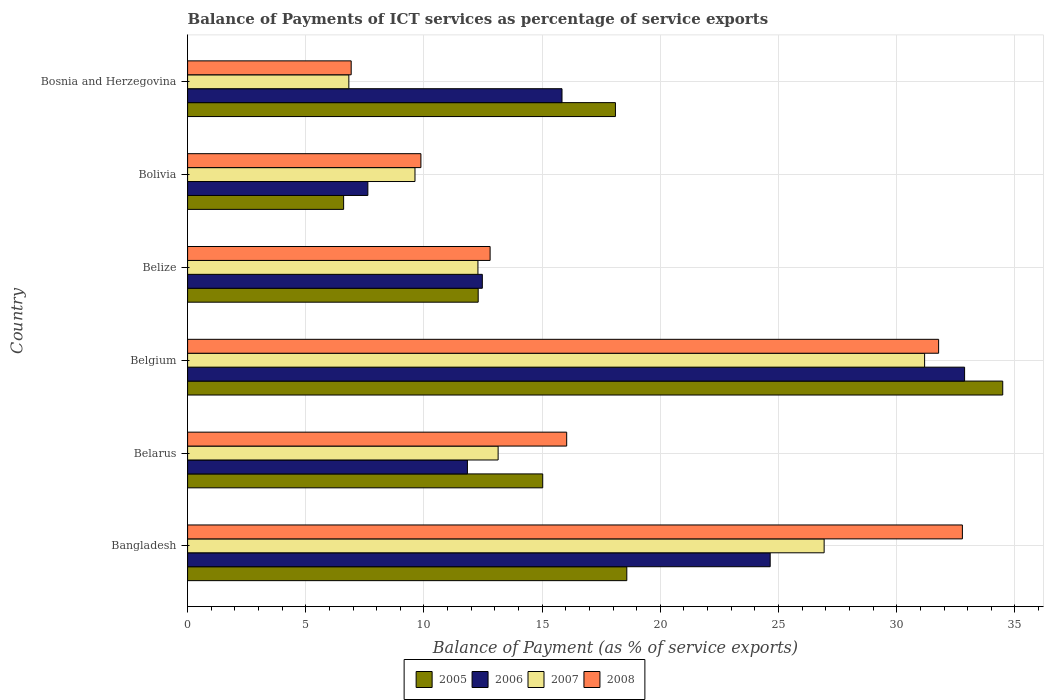How many different coloured bars are there?
Your response must be concise. 4. How many groups of bars are there?
Provide a short and direct response. 6. Are the number of bars per tick equal to the number of legend labels?
Provide a succinct answer. Yes. How many bars are there on the 1st tick from the top?
Your answer should be very brief. 4. How many bars are there on the 2nd tick from the bottom?
Your answer should be very brief. 4. What is the label of the 5th group of bars from the top?
Your answer should be very brief. Belarus. What is the balance of payments of ICT services in 2007 in Belarus?
Provide a succinct answer. 13.14. Across all countries, what is the maximum balance of payments of ICT services in 2007?
Make the answer very short. 31.18. Across all countries, what is the minimum balance of payments of ICT services in 2005?
Keep it short and to the point. 6.6. In which country was the balance of payments of ICT services in 2006 minimum?
Your answer should be compact. Bolivia. What is the total balance of payments of ICT services in 2006 in the graph?
Ensure brevity in your answer.  105.29. What is the difference between the balance of payments of ICT services in 2007 in Belgium and that in Bolivia?
Ensure brevity in your answer.  21.56. What is the difference between the balance of payments of ICT services in 2006 in Bangladesh and the balance of payments of ICT services in 2007 in Belgium?
Ensure brevity in your answer.  -6.53. What is the average balance of payments of ICT services in 2005 per country?
Your answer should be very brief. 17.51. What is the difference between the balance of payments of ICT services in 2008 and balance of payments of ICT services in 2006 in Belarus?
Your answer should be very brief. 4.2. What is the ratio of the balance of payments of ICT services in 2005 in Belize to that in Bolivia?
Provide a succinct answer. 1.86. Is the difference between the balance of payments of ICT services in 2008 in Bangladesh and Bolivia greater than the difference between the balance of payments of ICT services in 2006 in Bangladesh and Bolivia?
Ensure brevity in your answer.  Yes. What is the difference between the highest and the second highest balance of payments of ICT services in 2008?
Provide a succinct answer. 1.01. What is the difference between the highest and the lowest balance of payments of ICT services in 2005?
Offer a terse response. 27.88. Is it the case that in every country, the sum of the balance of payments of ICT services in 2007 and balance of payments of ICT services in 2008 is greater than the balance of payments of ICT services in 2006?
Your answer should be compact. No. How many bars are there?
Ensure brevity in your answer.  24. How many countries are there in the graph?
Your answer should be very brief. 6. Are the values on the major ticks of X-axis written in scientific E-notation?
Provide a succinct answer. No. Does the graph contain any zero values?
Make the answer very short. No. What is the title of the graph?
Provide a succinct answer. Balance of Payments of ICT services as percentage of service exports. What is the label or title of the X-axis?
Your answer should be very brief. Balance of Payment (as % of service exports). What is the Balance of Payment (as % of service exports) in 2005 in Bangladesh?
Keep it short and to the point. 18.58. What is the Balance of Payment (as % of service exports) in 2006 in Bangladesh?
Your answer should be very brief. 24.65. What is the Balance of Payment (as % of service exports) of 2007 in Bangladesh?
Your answer should be compact. 26.93. What is the Balance of Payment (as % of service exports) of 2008 in Bangladesh?
Keep it short and to the point. 32.78. What is the Balance of Payment (as % of service exports) in 2005 in Belarus?
Provide a short and direct response. 15.02. What is the Balance of Payment (as % of service exports) in 2006 in Belarus?
Offer a very short reply. 11.84. What is the Balance of Payment (as % of service exports) of 2007 in Belarus?
Give a very brief answer. 13.14. What is the Balance of Payment (as % of service exports) of 2008 in Belarus?
Give a very brief answer. 16.04. What is the Balance of Payment (as % of service exports) in 2005 in Belgium?
Your answer should be very brief. 34.48. What is the Balance of Payment (as % of service exports) in 2006 in Belgium?
Your answer should be very brief. 32.87. What is the Balance of Payment (as % of service exports) in 2007 in Belgium?
Your answer should be compact. 31.18. What is the Balance of Payment (as % of service exports) of 2008 in Belgium?
Your answer should be very brief. 31.77. What is the Balance of Payment (as % of service exports) of 2005 in Belize?
Your response must be concise. 12.29. What is the Balance of Payment (as % of service exports) of 2006 in Belize?
Your answer should be very brief. 12.47. What is the Balance of Payment (as % of service exports) in 2007 in Belize?
Your response must be concise. 12.28. What is the Balance of Payment (as % of service exports) in 2008 in Belize?
Provide a short and direct response. 12.8. What is the Balance of Payment (as % of service exports) of 2005 in Bolivia?
Provide a short and direct response. 6.6. What is the Balance of Payment (as % of service exports) in 2006 in Bolivia?
Provide a succinct answer. 7.63. What is the Balance of Payment (as % of service exports) of 2007 in Bolivia?
Make the answer very short. 9.62. What is the Balance of Payment (as % of service exports) in 2008 in Bolivia?
Your answer should be compact. 9.87. What is the Balance of Payment (as % of service exports) of 2005 in Bosnia and Herzegovina?
Give a very brief answer. 18.1. What is the Balance of Payment (as % of service exports) of 2006 in Bosnia and Herzegovina?
Give a very brief answer. 15.84. What is the Balance of Payment (as % of service exports) of 2007 in Bosnia and Herzegovina?
Your response must be concise. 6.82. What is the Balance of Payment (as % of service exports) in 2008 in Bosnia and Herzegovina?
Offer a very short reply. 6.92. Across all countries, what is the maximum Balance of Payment (as % of service exports) in 2005?
Give a very brief answer. 34.48. Across all countries, what is the maximum Balance of Payment (as % of service exports) in 2006?
Provide a short and direct response. 32.87. Across all countries, what is the maximum Balance of Payment (as % of service exports) in 2007?
Keep it short and to the point. 31.18. Across all countries, what is the maximum Balance of Payment (as % of service exports) of 2008?
Offer a very short reply. 32.78. Across all countries, what is the minimum Balance of Payment (as % of service exports) in 2005?
Make the answer very short. 6.6. Across all countries, what is the minimum Balance of Payment (as % of service exports) in 2006?
Provide a short and direct response. 7.63. Across all countries, what is the minimum Balance of Payment (as % of service exports) in 2007?
Give a very brief answer. 6.82. Across all countries, what is the minimum Balance of Payment (as % of service exports) in 2008?
Ensure brevity in your answer.  6.92. What is the total Balance of Payment (as % of service exports) in 2005 in the graph?
Ensure brevity in your answer.  105.08. What is the total Balance of Payment (as % of service exports) in 2006 in the graph?
Your answer should be very brief. 105.29. What is the total Balance of Payment (as % of service exports) in 2007 in the graph?
Keep it short and to the point. 99.97. What is the total Balance of Payment (as % of service exports) in 2008 in the graph?
Offer a very short reply. 110.18. What is the difference between the Balance of Payment (as % of service exports) of 2005 in Bangladesh and that in Belarus?
Your response must be concise. 3.56. What is the difference between the Balance of Payment (as % of service exports) of 2006 in Bangladesh and that in Belarus?
Provide a succinct answer. 12.81. What is the difference between the Balance of Payment (as % of service exports) in 2007 in Bangladesh and that in Belarus?
Give a very brief answer. 13.79. What is the difference between the Balance of Payment (as % of service exports) in 2008 in Bangladesh and that in Belarus?
Keep it short and to the point. 16.74. What is the difference between the Balance of Payment (as % of service exports) in 2005 in Bangladesh and that in Belgium?
Ensure brevity in your answer.  -15.9. What is the difference between the Balance of Payment (as % of service exports) of 2006 in Bangladesh and that in Belgium?
Offer a very short reply. -8.22. What is the difference between the Balance of Payment (as % of service exports) in 2007 in Bangladesh and that in Belgium?
Your answer should be very brief. -4.25. What is the difference between the Balance of Payment (as % of service exports) in 2005 in Bangladesh and that in Belize?
Provide a short and direct response. 6.29. What is the difference between the Balance of Payment (as % of service exports) of 2006 in Bangladesh and that in Belize?
Provide a short and direct response. 12.18. What is the difference between the Balance of Payment (as % of service exports) of 2007 in Bangladesh and that in Belize?
Your response must be concise. 14.65. What is the difference between the Balance of Payment (as % of service exports) of 2008 in Bangladesh and that in Belize?
Offer a very short reply. 19.98. What is the difference between the Balance of Payment (as % of service exports) of 2005 in Bangladesh and that in Bolivia?
Give a very brief answer. 11.98. What is the difference between the Balance of Payment (as % of service exports) of 2006 in Bangladesh and that in Bolivia?
Ensure brevity in your answer.  17.02. What is the difference between the Balance of Payment (as % of service exports) of 2007 in Bangladesh and that in Bolivia?
Offer a terse response. 17.31. What is the difference between the Balance of Payment (as % of service exports) of 2008 in Bangladesh and that in Bolivia?
Your answer should be compact. 22.91. What is the difference between the Balance of Payment (as % of service exports) of 2005 in Bangladesh and that in Bosnia and Herzegovina?
Give a very brief answer. 0.48. What is the difference between the Balance of Payment (as % of service exports) of 2006 in Bangladesh and that in Bosnia and Herzegovina?
Provide a succinct answer. 8.81. What is the difference between the Balance of Payment (as % of service exports) of 2007 in Bangladesh and that in Bosnia and Herzegovina?
Your answer should be compact. 20.11. What is the difference between the Balance of Payment (as % of service exports) in 2008 in Bangladesh and that in Bosnia and Herzegovina?
Offer a terse response. 25.86. What is the difference between the Balance of Payment (as % of service exports) in 2005 in Belarus and that in Belgium?
Offer a terse response. -19.46. What is the difference between the Balance of Payment (as % of service exports) in 2006 in Belarus and that in Belgium?
Give a very brief answer. -21.03. What is the difference between the Balance of Payment (as % of service exports) of 2007 in Belarus and that in Belgium?
Offer a terse response. -18.04. What is the difference between the Balance of Payment (as % of service exports) of 2008 in Belarus and that in Belgium?
Your answer should be very brief. -15.73. What is the difference between the Balance of Payment (as % of service exports) of 2005 in Belarus and that in Belize?
Your answer should be very brief. 2.73. What is the difference between the Balance of Payment (as % of service exports) of 2006 in Belarus and that in Belize?
Ensure brevity in your answer.  -0.63. What is the difference between the Balance of Payment (as % of service exports) of 2007 in Belarus and that in Belize?
Make the answer very short. 0.85. What is the difference between the Balance of Payment (as % of service exports) in 2008 in Belarus and that in Belize?
Provide a succinct answer. 3.24. What is the difference between the Balance of Payment (as % of service exports) in 2005 in Belarus and that in Bolivia?
Ensure brevity in your answer.  8.42. What is the difference between the Balance of Payment (as % of service exports) in 2006 in Belarus and that in Bolivia?
Offer a very short reply. 4.21. What is the difference between the Balance of Payment (as % of service exports) of 2007 in Belarus and that in Bolivia?
Your answer should be very brief. 3.52. What is the difference between the Balance of Payment (as % of service exports) in 2008 in Belarus and that in Bolivia?
Give a very brief answer. 6.17. What is the difference between the Balance of Payment (as % of service exports) of 2005 in Belarus and that in Bosnia and Herzegovina?
Give a very brief answer. -3.08. What is the difference between the Balance of Payment (as % of service exports) of 2006 in Belarus and that in Bosnia and Herzegovina?
Make the answer very short. -4. What is the difference between the Balance of Payment (as % of service exports) in 2007 in Belarus and that in Bosnia and Herzegovina?
Offer a very short reply. 6.32. What is the difference between the Balance of Payment (as % of service exports) of 2008 in Belarus and that in Bosnia and Herzegovina?
Provide a succinct answer. 9.12. What is the difference between the Balance of Payment (as % of service exports) in 2005 in Belgium and that in Belize?
Keep it short and to the point. 22.19. What is the difference between the Balance of Payment (as % of service exports) in 2006 in Belgium and that in Belize?
Your answer should be compact. 20.4. What is the difference between the Balance of Payment (as % of service exports) in 2007 in Belgium and that in Belize?
Offer a terse response. 18.9. What is the difference between the Balance of Payment (as % of service exports) of 2008 in Belgium and that in Belize?
Ensure brevity in your answer.  18.97. What is the difference between the Balance of Payment (as % of service exports) of 2005 in Belgium and that in Bolivia?
Provide a succinct answer. 27.88. What is the difference between the Balance of Payment (as % of service exports) of 2006 in Belgium and that in Bolivia?
Your answer should be compact. 25.24. What is the difference between the Balance of Payment (as % of service exports) of 2007 in Belgium and that in Bolivia?
Offer a terse response. 21.56. What is the difference between the Balance of Payment (as % of service exports) of 2008 in Belgium and that in Bolivia?
Provide a short and direct response. 21.9. What is the difference between the Balance of Payment (as % of service exports) of 2005 in Belgium and that in Bosnia and Herzegovina?
Provide a succinct answer. 16.39. What is the difference between the Balance of Payment (as % of service exports) of 2006 in Belgium and that in Bosnia and Herzegovina?
Provide a short and direct response. 17.03. What is the difference between the Balance of Payment (as % of service exports) of 2007 in Belgium and that in Bosnia and Herzegovina?
Ensure brevity in your answer.  24.36. What is the difference between the Balance of Payment (as % of service exports) in 2008 in Belgium and that in Bosnia and Herzegovina?
Ensure brevity in your answer.  24.85. What is the difference between the Balance of Payment (as % of service exports) of 2005 in Belize and that in Bolivia?
Keep it short and to the point. 5.69. What is the difference between the Balance of Payment (as % of service exports) of 2006 in Belize and that in Bolivia?
Make the answer very short. 4.84. What is the difference between the Balance of Payment (as % of service exports) of 2007 in Belize and that in Bolivia?
Make the answer very short. 2.66. What is the difference between the Balance of Payment (as % of service exports) of 2008 in Belize and that in Bolivia?
Provide a succinct answer. 2.93. What is the difference between the Balance of Payment (as % of service exports) of 2005 in Belize and that in Bosnia and Herzegovina?
Your answer should be very brief. -5.81. What is the difference between the Balance of Payment (as % of service exports) of 2006 in Belize and that in Bosnia and Herzegovina?
Provide a succinct answer. -3.37. What is the difference between the Balance of Payment (as % of service exports) in 2007 in Belize and that in Bosnia and Herzegovina?
Provide a succinct answer. 5.46. What is the difference between the Balance of Payment (as % of service exports) in 2008 in Belize and that in Bosnia and Herzegovina?
Offer a very short reply. 5.88. What is the difference between the Balance of Payment (as % of service exports) of 2005 in Bolivia and that in Bosnia and Herzegovina?
Your answer should be compact. -11.5. What is the difference between the Balance of Payment (as % of service exports) in 2006 in Bolivia and that in Bosnia and Herzegovina?
Provide a short and direct response. -8.21. What is the difference between the Balance of Payment (as % of service exports) of 2007 in Bolivia and that in Bosnia and Herzegovina?
Make the answer very short. 2.8. What is the difference between the Balance of Payment (as % of service exports) of 2008 in Bolivia and that in Bosnia and Herzegovina?
Make the answer very short. 2.95. What is the difference between the Balance of Payment (as % of service exports) of 2005 in Bangladesh and the Balance of Payment (as % of service exports) of 2006 in Belarus?
Provide a succinct answer. 6.74. What is the difference between the Balance of Payment (as % of service exports) of 2005 in Bangladesh and the Balance of Payment (as % of service exports) of 2007 in Belarus?
Your answer should be compact. 5.44. What is the difference between the Balance of Payment (as % of service exports) in 2005 in Bangladesh and the Balance of Payment (as % of service exports) in 2008 in Belarus?
Your answer should be compact. 2.54. What is the difference between the Balance of Payment (as % of service exports) of 2006 in Bangladesh and the Balance of Payment (as % of service exports) of 2007 in Belarus?
Give a very brief answer. 11.51. What is the difference between the Balance of Payment (as % of service exports) in 2006 in Bangladesh and the Balance of Payment (as % of service exports) in 2008 in Belarus?
Provide a short and direct response. 8.61. What is the difference between the Balance of Payment (as % of service exports) of 2007 in Bangladesh and the Balance of Payment (as % of service exports) of 2008 in Belarus?
Your response must be concise. 10.89. What is the difference between the Balance of Payment (as % of service exports) of 2005 in Bangladesh and the Balance of Payment (as % of service exports) of 2006 in Belgium?
Keep it short and to the point. -14.29. What is the difference between the Balance of Payment (as % of service exports) of 2005 in Bangladesh and the Balance of Payment (as % of service exports) of 2007 in Belgium?
Give a very brief answer. -12.6. What is the difference between the Balance of Payment (as % of service exports) in 2005 in Bangladesh and the Balance of Payment (as % of service exports) in 2008 in Belgium?
Offer a terse response. -13.19. What is the difference between the Balance of Payment (as % of service exports) of 2006 in Bangladesh and the Balance of Payment (as % of service exports) of 2007 in Belgium?
Provide a short and direct response. -6.53. What is the difference between the Balance of Payment (as % of service exports) of 2006 in Bangladesh and the Balance of Payment (as % of service exports) of 2008 in Belgium?
Offer a very short reply. -7.13. What is the difference between the Balance of Payment (as % of service exports) of 2007 in Bangladesh and the Balance of Payment (as % of service exports) of 2008 in Belgium?
Offer a terse response. -4.84. What is the difference between the Balance of Payment (as % of service exports) in 2005 in Bangladesh and the Balance of Payment (as % of service exports) in 2006 in Belize?
Give a very brief answer. 6.11. What is the difference between the Balance of Payment (as % of service exports) of 2005 in Bangladesh and the Balance of Payment (as % of service exports) of 2007 in Belize?
Keep it short and to the point. 6.3. What is the difference between the Balance of Payment (as % of service exports) of 2005 in Bangladesh and the Balance of Payment (as % of service exports) of 2008 in Belize?
Keep it short and to the point. 5.78. What is the difference between the Balance of Payment (as % of service exports) of 2006 in Bangladesh and the Balance of Payment (as % of service exports) of 2007 in Belize?
Provide a succinct answer. 12.36. What is the difference between the Balance of Payment (as % of service exports) in 2006 in Bangladesh and the Balance of Payment (as % of service exports) in 2008 in Belize?
Give a very brief answer. 11.85. What is the difference between the Balance of Payment (as % of service exports) of 2007 in Bangladesh and the Balance of Payment (as % of service exports) of 2008 in Belize?
Make the answer very short. 14.13. What is the difference between the Balance of Payment (as % of service exports) of 2005 in Bangladesh and the Balance of Payment (as % of service exports) of 2006 in Bolivia?
Your response must be concise. 10.96. What is the difference between the Balance of Payment (as % of service exports) of 2005 in Bangladesh and the Balance of Payment (as % of service exports) of 2007 in Bolivia?
Offer a terse response. 8.96. What is the difference between the Balance of Payment (as % of service exports) of 2005 in Bangladesh and the Balance of Payment (as % of service exports) of 2008 in Bolivia?
Offer a terse response. 8.71. What is the difference between the Balance of Payment (as % of service exports) in 2006 in Bangladesh and the Balance of Payment (as % of service exports) in 2007 in Bolivia?
Provide a short and direct response. 15.03. What is the difference between the Balance of Payment (as % of service exports) in 2006 in Bangladesh and the Balance of Payment (as % of service exports) in 2008 in Bolivia?
Give a very brief answer. 14.78. What is the difference between the Balance of Payment (as % of service exports) in 2007 in Bangladesh and the Balance of Payment (as % of service exports) in 2008 in Bolivia?
Provide a short and direct response. 17.06. What is the difference between the Balance of Payment (as % of service exports) of 2005 in Bangladesh and the Balance of Payment (as % of service exports) of 2006 in Bosnia and Herzegovina?
Offer a terse response. 2.74. What is the difference between the Balance of Payment (as % of service exports) of 2005 in Bangladesh and the Balance of Payment (as % of service exports) of 2007 in Bosnia and Herzegovina?
Provide a succinct answer. 11.76. What is the difference between the Balance of Payment (as % of service exports) in 2005 in Bangladesh and the Balance of Payment (as % of service exports) in 2008 in Bosnia and Herzegovina?
Provide a succinct answer. 11.66. What is the difference between the Balance of Payment (as % of service exports) of 2006 in Bangladesh and the Balance of Payment (as % of service exports) of 2007 in Bosnia and Herzegovina?
Your answer should be very brief. 17.83. What is the difference between the Balance of Payment (as % of service exports) of 2006 in Bangladesh and the Balance of Payment (as % of service exports) of 2008 in Bosnia and Herzegovina?
Your answer should be compact. 17.73. What is the difference between the Balance of Payment (as % of service exports) in 2007 in Bangladesh and the Balance of Payment (as % of service exports) in 2008 in Bosnia and Herzegovina?
Make the answer very short. 20.01. What is the difference between the Balance of Payment (as % of service exports) in 2005 in Belarus and the Balance of Payment (as % of service exports) in 2006 in Belgium?
Offer a terse response. -17.85. What is the difference between the Balance of Payment (as % of service exports) in 2005 in Belarus and the Balance of Payment (as % of service exports) in 2007 in Belgium?
Ensure brevity in your answer.  -16.16. What is the difference between the Balance of Payment (as % of service exports) in 2005 in Belarus and the Balance of Payment (as % of service exports) in 2008 in Belgium?
Your answer should be very brief. -16.75. What is the difference between the Balance of Payment (as % of service exports) in 2006 in Belarus and the Balance of Payment (as % of service exports) in 2007 in Belgium?
Your response must be concise. -19.34. What is the difference between the Balance of Payment (as % of service exports) in 2006 in Belarus and the Balance of Payment (as % of service exports) in 2008 in Belgium?
Ensure brevity in your answer.  -19.93. What is the difference between the Balance of Payment (as % of service exports) of 2007 in Belarus and the Balance of Payment (as % of service exports) of 2008 in Belgium?
Provide a short and direct response. -18.64. What is the difference between the Balance of Payment (as % of service exports) of 2005 in Belarus and the Balance of Payment (as % of service exports) of 2006 in Belize?
Provide a short and direct response. 2.55. What is the difference between the Balance of Payment (as % of service exports) in 2005 in Belarus and the Balance of Payment (as % of service exports) in 2007 in Belize?
Your response must be concise. 2.74. What is the difference between the Balance of Payment (as % of service exports) of 2005 in Belarus and the Balance of Payment (as % of service exports) of 2008 in Belize?
Provide a succinct answer. 2.23. What is the difference between the Balance of Payment (as % of service exports) in 2006 in Belarus and the Balance of Payment (as % of service exports) in 2007 in Belize?
Your response must be concise. -0.44. What is the difference between the Balance of Payment (as % of service exports) of 2006 in Belarus and the Balance of Payment (as % of service exports) of 2008 in Belize?
Your answer should be compact. -0.96. What is the difference between the Balance of Payment (as % of service exports) in 2007 in Belarus and the Balance of Payment (as % of service exports) in 2008 in Belize?
Offer a very short reply. 0.34. What is the difference between the Balance of Payment (as % of service exports) in 2005 in Belarus and the Balance of Payment (as % of service exports) in 2006 in Bolivia?
Provide a succinct answer. 7.4. What is the difference between the Balance of Payment (as % of service exports) in 2005 in Belarus and the Balance of Payment (as % of service exports) in 2007 in Bolivia?
Provide a short and direct response. 5.4. What is the difference between the Balance of Payment (as % of service exports) in 2005 in Belarus and the Balance of Payment (as % of service exports) in 2008 in Bolivia?
Offer a terse response. 5.15. What is the difference between the Balance of Payment (as % of service exports) in 2006 in Belarus and the Balance of Payment (as % of service exports) in 2007 in Bolivia?
Provide a short and direct response. 2.22. What is the difference between the Balance of Payment (as % of service exports) in 2006 in Belarus and the Balance of Payment (as % of service exports) in 2008 in Bolivia?
Make the answer very short. 1.97. What is the difference between the Balance of Payment (as % of service exports) of 2007 in Belarus and the Balance of Payment (as % of service exports) of 2008 in Bolivia?
Keep it short and to the point. 3.27. What is the difference between the Balance of Payment (as % of service exports) in 2005 in Belarus and the Balance of Payment (as % of service exports) in 2006 in Bosnia and Herzegovina?
Your response must be concise. -0.82. What is the difference between the Balance of Payment (as % of service exports) of 2005 in Belarus and the Balance of Payment (as % of service exports) of 2007 in Bosnia and Herzegovina?
Offer a very short reply. 8.2. What is the difference between the Balance of Payment (as % of service exports) of 2005 in Belarus and the Balance of Payment (as % of service exports) of 2008 in Bosnia and Herzegovina?
Provide a short and direct response. 8.1. What is the difference between the Balance of Payment (as % of service exports) in 2006 in Belarus and the Balance of Payment (as % of service exports) in 2007 in Bosnia and Herzegovina?
Keep it short and to the point. 5.02. What is the difference between the Balance of Payment (as % of service exports) in 2006 in Belarus and the Balance of Payment (as % of service exports) in 2008 in Bosnia and Herzegovina?
Provide a short and direct response. 4.92. What is the difference between the Balance of Payment (as % of service exports) in 2007 in Belarus and the Balance of Payment (as % of service exports) in 2008 in Bosnia and Herzegovina?
Offer a very short reply. 6.22. What is the difference between the Balance of Payment (as % of service exports) of 2005 in Belgium and the Balance of Payment (as % of service exports) of 2006 in Belize?
Your response must be concise. 22.02. What is the difference between the Balance of Payment (as % of service exports) in 2005 in Belgium and the Balance of Payment (as % of service exports) in 2007 in Belize?
Give a very brief answer. 22.2. What is the difference between the Balance of Payment (as % of service exports) in 2005 in Belgium and the Balance of Payment (as % of service exports) in 2008 in Belize?
Provide a short and direct response. 21.69. What is the difference between the Balance of Payment (as % of service exports) in 2006 in Belgium and the Balance of Payment (as % of service exports) in 2007 in Belize?
Keep it short and to the point. 20.59. What is the difference between the Balance of Payment (as % of service exports) in 2006 in Belgium and the Balance of Payment (as % of service exports) in 2008 in Belize?
Offer a terse response. 20.07. What is the difference between the Balance of Payment (as % of service exports) in 2007 in Belgium and the Balance of Payment (as % of service exports) in 2008 in Belize?
Your answer should be very brief. 18.38. What is the difference between the Balance of Payment (as % of service exports) in 2005 in Belgium and the Balance of Payment (as % of service exports) in 2006 in Bolivia?
Your answer should be very brief. 26.86. What is the difference between the Balance of Payment (as % of service exports) in 2005 in Belgium and the Balance of Payment (as % of service exports) in 2007 in Bolivia?
Provide a short and direct response. 24.87. What is the difference between the Balance of Payment (as % of service exports) of 2005 in Belgium and the Balance of Payment (as % of service exports) of 2008 in Bolivia?
Offer a terse response. 24.61. What is the difference between the Balance of Payment (as % of service exports) of 2006 in Belgium and the Balance of Payment (as % of service exports) of 2007 in Bolivia?
Provide a short and direct response. 23.25. What is the difference between the Balance of Payment (as % of service exports) of 2006 in Belgium and the Balance of Payment (as % of service exports) of 2008 in Bolivia?
Your response must be concise. 23. What is the difference between the Balance of Payment (as % of service exports) in 2007 in Belgium and the Balance of Payment (as % of service exports) in 2008 in Bolivia?
Your response must be concise. 21.31. What is the difference between the Balance of Payment (as % of service exports) of 2005 in Belgium and the Balance of Payment (as % of service exports) of 2006 in Bosnia and Herzegovina?
Provide a succinct answer. 18.65. What is the difference between the Balance of Payment (as % of service exports) of 2005 in Belgium and the Balance of Payment (as % of service exports) of 2007 in Bosnia and Herzegovina?
Provide a succinct answer. 27.66. What is the difference between the Balance of Payment (as % of service exports) of 2005 in Belgium and the Balance of Payment (as % of service exports) of 2008 in Bosnia and Herzegovina?
Make the answer very short. 27.56. What is the difference between the Balance of Payment (as % of service exports) of 2006 in Belgium and the Balance of Payment (as % of service exports) of 2007 in Bosnia and Herzegovina?
Give a very brief answer. 26.05. What is the difference between the Balance of Payment (as % of service exports) in 2006 in Belgium and the Balance of Payment (as % of service exports) in 2008 in Bosnia and Herzegovina?
Provide a short and direct response. 25.95. What is the difference between the Balance of Payment (as % of service exports) of 2007 in Belgium and the Balance of Payment (as % of service exports) of 2008 in Bosnia and Herzegovina?
Provide a short and direct response. 24.26. What is the difference between the Balance of Payment (as % of service exports) in 2005 in Belize and the Balance of Payment (as % of service exports) in 2006 in Bolivia?
Your answer should be compact. 4.67. What is the difference between the Balance of Payment (as % of service exports) in 2005 in Belize and the Balance of Payment (as % of service exports) in 2007 in Bolivia?
Offer a terse response. 2.67. What is the difference between the Balance of Payment (as % of service exports) of 2005 in Belize and the Balance of Payment (as % of service exports) of 2008 in Bolivia?
Give a very brief answer. 2.42. What is the difference between the Balance of Payment (as % of service exports) of 2006 in Belize and the Balance of Payment (as % of service exports) of 2007 in Bolivia?
Give a very brief answer. 2.85. What is the difference between the Balance of Payment (as % of service exports) in 2006 in Belize and the Balance of Payment (as % of service exports) in 2008 in Bolivia?
Provide a short and direct response. 2.6. What is the difference between the Balance of Payment (as % of service exports) of 2007 in Belize and the Balance of Payment (as % of service exports) of 2008 in Bolivia?
Your answer should be compact. 2.41. What is the difference between the Balance of Payment (as % of service exports) in 2005 in Belize and the Balance of Payment (as % of service exports) in 2006 in Bosnia and Herzegovina?
Offer a very short reply. -3.55. What is the difference between the Balance of Payment (as % of service exports) of 2005 in Belize and the Balance of Payment (as % of service exports) of 2007 in Bosnia and Herzegovina?
Ensure brevity in your answer.  5.47. What is the difference between the Balance of Payment (as % of service exports) of 2005 in Belize and the Balance of Payment (as % of service exports) of 2008 in Bosnia and Herzegovina?
Offer a terse response. 5.37. What is the difference between the Balance of Payment (as % of service exports) in 2006 in Belize and the Balance of Payment (as % of service exports) in 2007 in Bosnia and Herzegovina?
Your answer should be very brief. 5.65. What is the difference between the Balance of Payment (as % of service exports) in 2006 in Belize and the Balance of Payment (as % of service exports) in 2008 in Bosnia and Herzegovina?
Offer a terse response. 5.55. What is the difference between the Balance of Payment (as % of service exports) of 2007 in Belize and the Balance of Payment (as % of service exports) of 2008 in Bosnia and Herzegovina?
Provide a succinct answer. 5.36. What is the difference between the Balance of Payment (as % of service exports) in 2005 in Bolivia and the Balance of Payment (as % of service exports) in 2006 in Bosnia and Herzegovina?
Give a very brief answer. -9.24. What is the difference between the Balance of Payment (as % of service exports) in 2005 in Bolivia and the Balance of Payment (as % of service exports) in 2007 in Bosnia and Herzegovina?
Provide a succinct answer. -0.22. What is the difference between the Balance of Payment (as % of service exports) in 2005 in Bolivia and the Balance of Payment (as % of service exports) in 2008 in Bosnia and Herzegovina?
Your answer should be compact. -0.32. What is the difference between the Balance of Payment (as % of service exports) of 2006 in Bolivia and the Balance of Payment (as % of service exports) of 2007 in Bosnia and Herzegovina?
Give a very brief answer. 0.8. What is the difference between the Balance of Payment (as % of service exports) of 2006 in Bolivia and the Balance of Payment (as % of service exports) of 2008 in Bosnia and Herzegovina?
Provide a succinct answer. 0.71. What is the difference between the Balance of Payment (as % of service exports) of 2007 in Bolivia and the Balance of Payment (as % of service exports) of 2008 in Bosnia and Herzegovina?
Your answer should be very brief. 2.7. What is the average Balance of Payment (as % of service exports) in 2005 per country?
Your response must be concise. 17.51. What is the average Balance of Payment (as % of service exports) of 2006 per country?
Keep it short and to the point. 17.55. What is the average Balance of Payment (as % of service exports) in 2007 per country?
Keep it short and to the point. 16.66. What is the average Balance of Payment (as % of service exports) in 2008 per country?
Provide a succinct answer. 18.36. What is the difference between the Balance of Payment (as % of service exports) in 2005 and Balance of Payment (as % of service exports) in 2006 in Bangladesh?
Ensure brevity in your answer.  -6.07. What is the difference between the Balance of Payment (as % of service exports) in 2005 and Balance of Payment (as % of service exports) in 2007 in Bangladesh?
Offer a very short reply. -8.35. What is the difference between the Balance of Payment (as % of service exports) in 2005 and Balance of Payment (as % of service exports) in 2008 in Bangladesh?
Provide a succinct answer. -14.2. What is the difference between the Balance of Payment (as % of service exports) in 2006 and Balance of Payment (as % of service exports) in 2007 in Bangladesh?
Keep it short and to the point. -2.28. What is the difference between the Balance of Payment (as % of service exports) in 2006 and Balance of Payment (as % of service exports) in 2008 in Bangladesh?
Offer a terse response. -8.13. What is the difference between the Balance of Payment (as % of service exports) in 2007 and Balance of Payment (as % of service exports) in 2008 in Bangladesh?
Your answer should be compact. -5.85. What is the difference between the Balance of Payment (as % of service exports) in 2005 and Balance of Payment (as % of service exports) in 2006 in Belarus?
Your response must be concise. 3.19. What is the difference between the Balance of Payment (as % of service exports) of 2005 and Balance of Payment (as % of service exports) of 2007 in Belarus?
Keep it short and to the point. 1.89. What is the difference between the Balance of Payment (as % of service exports) of 2005 and Balance of Payment (as % of service exports) of 2008 in Belarus?
Provide a succinct answer. -1.01. What is the difference between the Balance of Payment (as % of service exports) in 2006 and Balance of Payment (as % of service exports) in 2007 in Belarus?
Your answer should be very brief. -1.3. What is the difference between the Balance of Payment (as % of service exports) in 2006 and Balance of Payment (as % of service exports) in 2008 in Belarus?
Keep it short and to the point. -4.2. What is the difference between the Balance of Payment (as % of service exports) of 2007 and Balance of Payment (as % of service exports) of 2008 in Belarus?
Provide a succinct answer. -2.9. What is the difference between the Balance of Payment (as % of service exports) of 2005 and Balance of Payment (as % of service exports) of 2006 in Belgium?
Your response must be concise. 1.61. What is the difference between the Balance of Payment (as % of service exports) of 2005 and Balance of Payment (as % of service exports) of 2007 in Belgium?
Your answer should be compact. 3.31. What is the difference between the Balance of Payment (as % of service exports) of 2005 and Balance of Payment (as % of service exports) of 2008 in Belgium?
Provide a succinct answer. 2.71. What is the difference between the Balance of Payment (as % of service exports) in 2006 and Balance of Payment (as % of service exports) in 2007 in Belgium?
Your answer should be compact. 1.69. What is the difference between the Balance of Payment (as % of service exports) of 2006 and Balance of Payment (as % of service exports) of 2008 in Belgium?
Your answer should be very brief. 1.1. What is the difference between the Balance of Payment (as % of service exports) in 2007 and Balance of Payment (as % of service exports) in 2008 in Belgium?
Give a very brief answer. -0.59. What is the difference between the Balance of Payment (as % of service exports) in 2005 and Balance of Payment (as % of service exports) in 2006 in Belize?
Your response must be concise. -0.18. What is the difference between the Balance of Payment (as % of service exports) in 2005 and Balance of Payment (as % of service exports) in 2007 in Belize?
Offer a very short reply. 0.01. What is the difference between the Balance of Payment (as % of service exports) in 2005 and Balance of Payment (as % of service exports) in 2008 in Belize?
Offer a very short reply. -0.5. What is the difference between the Balance of Payment (as % of service exports) of 2006 and Balance of Payment (as % of service exports) of 2007 in Belize?
Make the answer very short. 0.19. What is the difference between the Balance of Payment (as % of service exports) of 2006 and Balance of Payment (as % of service exports) of 2008 in Belize?
Make the answer very short. -0.33. What is the difference between the Balance of Payment (as % of service exports) of 2007 and Balance of Payment (as % of service exports) of 2008 in Belize?
Offer a terse response. -0.52. What is the difference between the Balance of Payment (as % of service exports) in 2005 and Balance of Payment (as % of service exports) in 2006 in Bolivia?
Ensure brevity in your answer.  -1.03. What is the difference between the Balance of Payment (as % of service exports) in 2005 and Balance of Payment (as % of service exports) in 2007 in Bolivia?
Ensure brevity in your answer.  -3.02. What is the difference between the Balance of Payment (as % of service exports) in 2005 and Balance of Payment (as % of service exports) in 2008 in Bolivia?
Provide a short and direct response. -3.27. What is the difference between the Balance of Payment (as % of service exports) of 2006 and Balance of Payment (as % of service exports) of 2007 in Bolivia?
Your answer should be compact. -1.99. What is the difference between the Balance of Payment (as % of service exports) of 2006 and Balance of Payment (as % of service exports) of 2008 in Bolivia?
Offer a very short reply. -2.24. What is the difference between the Balance of Payment (as % of service exports) in 2007 and Balance of Payment (as % of service exports) in 2008 in Bolivia?
Make the answer very short. -0.25. What is the difference between the Balance of Payment (as % of service exports) in 2005 and Balance of Payment (as % of service exports) in 2006 in Bosnia and Herzegovina?
Your answer should be compact. 2.26. What is the difference between the Balance of Payment (as % of service exports) in 2005 and Balance of Payment (as % of service exports) in 2007 in Bosnia and Herzegovina?
Ensure brevity in your answer.  11.28. What is the difference between the Balance of Payment (as % of service exports) of 2005 and Balance of Payment (as % of service exports) of 2008 in Bosnia and Herzegovina?
Give a very brief answer. 11.18. What is the difference between the Balance of Payment (as % of service exports) of 2006 and Balance of Payment (as % of service exports) of 2007 in Bosnia and Herzegovina?
Keep it short and to the point. 9.02. What is the difference between the Balance of Payment (as % of service exports) in 2006 and Balance of Payment (as % of service exports) in 2008 in Bosnia and Herzegovina?
Make the answer very short. 8.92. What is the difference between the Balance of Payment (as % of service exports) in 2007 and Balance of Payment (as % of service exports) in 2008 in Bosnia and Herzegovina?
Give a very brief answer. -0.1. What is the ratio of the Balance of Payment (as % of service exports) in 2005 in Bangladesh to that in Belarus?
Provide a succinct answer. 1.24. What is the ratio of the Balance of Payment (as % of service exports) in 2006 in Bangladesh to that in Belarus?
Provide a short and direct response. 2.08. What is the ratio of the Balance of Payment (as % of service exports) of 2007 in Bangladesh to that in Belarus?
Your response must be concise. 2.05. What is the ratio of the Balance of Payment (as % of service exports) in 2008 in Bangladesh to that in Belarus?
Provide a succinct answer. 2.04. What is the ratio of the Balance of Payment (as % of service exports) of 2005 in Bangladesh to that in Belgium?
Your answer should be very brief. 0.54. What is the ratio of the Balance of Payment (as % of service exports) in 2006 in Bangladesh to that in Belgium?
Keep it short and to the point. 0.75. What is the ratio of the Balance of Payment (as % of service exports) of 2007 in Bangladesh to that in Belgium?
Your answer should be compact. 0.86. What is the ratio of the Balance of Payment (as % of service exports) of 2008 in Bangladesh to that in Belgium?
Keep it short and to the point. 1.03. What is the ratio of the Balance of Payment (as % of service exports) of 2005 in Bangladesh to that in Belize?
Your response must be concise. 1.51. What is the ratio of the Balance of Payment (as % of service exports) in 2006 in Bangladesh to that in Belize?
Keep it short and to the point. 1.98. What is the ratio of the Balance of Payment (as % of service exports) in 2007 in Bangladesh to that in Belize?
Your response must be concise. 2.19. What is the ratio of the Balance of Payment (as % of service exports) of 2008 in Bangladesh to that in Belize?
Your answer should be compact. 2.56. What is the ratio of the Balance of Payment (as % of service exports) of 2005 in Bangladesh to that in Bolivia?
Provide a short and direct response. 2.81. What is the ratio of the Balance of Payment (as % of service exports) of 2006 in Bangladesh to that in Bolivia?
Offer a terse response. 3.23. What is the ratio of the Balance of Payment (as % of service exports) in 2007 in Bangladesh to that in Bolivia?
Provide a short and direct response. 2.8. What is the ratio of the Balance of Payment (as % of service exports) of 2008 in Bangladesh to that in Bolivia?
Your answer should be compact. 3.32. What is the ratio of the Balance of Payment (as % of service exports) in 2005 in Bangladesh to that in Bosnia and Herzegovina?
Give a very brief answer. 1.03. What is the ratio of the Balance of Payment (as % of service exports) in 2006 in Bangladesh to that in Bosnia and Herzegovina?
Give a very brief answer. 1.56. What is the ratio of the Balance of Payment (as % of service exports) of 2007 in Bangladesh to that in Bosnia and Herzegovina?
Provide a short and direct response. 3.95. What is the ratio of the Balance of Payment (as % of service exports) in 2008 in Bangladesh to that in Bosnia and Herzegovina?
Offer a terse response. 4.74. What is the ratio of the Balance of Payment (as % of service exports) of 2005 in Belarus to that in Belgium?
Provide a short and direct response. 0.44. What is the ratio of the Balance of Payment (as % of service exports) of 2006 in Belarus to that in Belgium?
Make the answer very short. 0.36. What is the ratio of the Balance of Payment (as % of service exports) in 2007 in Belarus to that in Belgium?
Provide a succinct answer. 0.42. What is the ratio of the Balance of Payment (as % of service exports) of 2008 in Belarus to that in Belgium?
Ensure brevity in your answer.  0.5. What is the ratio of the Balance of Payment (as % of service exports) of 2005 in Belarus to that in Belize?
Ensure brevity in your answer.  1.22. What is the ratio of the Balance of Payment (as % of service exports) of 2006 in Belarus to that in Belize?
Offer a terse response. 0.95. What is the ratio of the Balance of Payment (as % of service exports) of 2007 in Belarus to that in Belize?
Ensure brevity in your answer.  1.07. What is the ratio of the Balance of Payment (as % of service exports) in 2008 in Belarus to that in Belize?
Offer a very short reply. 1.25. What is the ratio of the Balance of Payment (as % of service exports) in 2005 in Belarus to that in Bolivia?
Ensure brevity in your answer.  2.28. What is the ratio of the Balance of Payment (as % of service exports) in 2006 in Belarus to that in Bolivia?
Make the answer very short. 1.55. What is the ratio of the Balance of Payment (as % of service exports) in 2007 in Belarus to that in Bolivia?
Keep it short and to the point. 1.37. What is the ratio of the Balance of Payment (as % of service exports) of 2008 in Belarus to that in Bolivia?
Your response must be concise. 1.62. What is the ratio of the Balance of Payment (as % of service exports) of 2005 in Belarus to that in Bosnia and Herzegovina?
Provide a succinct answer. 0.83. What is the ratio of the Balance of Payment (as % of service exports) in 2006 in Belarus to that in Bosnia and Herzegovina?
Your answer should be compact. 0.75. What is the ratio of the Balance of Payment (as % of service exports) of 2007 in Belarus to that in Bosnia and Herzegovina?
Offer a very short reply. 1.93. What is the ratio of the Balance of Payment (as % of service exports) in 2008 in Belarus to that in Bosnia and Herzegovina?
Give a very brief answer. 2.32. What is the ratio of the Balance of Payment (as % of service exports) in 2005 in Belgium to that in Belize?
Provide a short and direct response. 2.81. What is the ratio of the Balance of Payment (as % of service exports) in 2006 in Belgium to that in Belize?
Your response must be concise. 2.64. What is the ratio of the Balance of Payment (as % of service exports) of 2007 in Belgium to that in Belize?
Your answer should be compact. 2.54. What is the ratio of the Balance of Payment (as % of service exports) in 2008 in Belgium to that in Belize?
Your answer should be very brief. 2.48. What is the ratio of the Balance of Payment (as % of service exports) in 2005 in Belgium to that in Bolivia?
Provide a succinct answer. 5.22. What is the ratio of the Balance of Payment (as % of service exports) in 2006 in Belgium to that in Bolivia?
Ensure brevity in your answer.  4.31. What is the ratio of the Balance of Payment (as % of service exports) in 2007 in Belgium to that in Bolivia?
Your response must be concise. 3.24. What is the ratio of the Balance of Payment (as % of service exports) of 2008 in Belgium to that in Bolivia?
Your response must be concise. 3.22. What is the ratio of the Balance of Payment (as % of service exports) in 2005 in Belgium to that in Bosnia and Herzegovina?
Your response must be concise. 1.91. What is the ratio of the Balance of Payment (as % of service exports) in 2006 in Belgium to that in Bosnia and Herzegovina?
Ensure brevity in your answer.  2.08. What is the ratio of the Balance of Payment (as % of service exports) in 2007 in Belgium to that in Bosnia and Herzegovina?
Keep it short and to the point. 4.57. What is the ratio of the Balance of Payment (as % of service exports) of 2008 in Belgium to that in Bosnia and Herzegovina?
Make the answer very short. 4.59. What is the ratio of the Balance of Payment (as % of service exports) of 2005 in Belize to that in Bolivia?
Offer a terse response. 1.86. What is the ratio of the Balance of Payment (as % of service exports) of 2006 in Belize to that in Bolivia?
Ensure brevity in your answer.  1.64. What is the ratio of the Balance of Payment (as % of service exports) in 2007 in Belize to that in Bolivia?
Your answer should be compact. 1.28. What is the ratio of the Balance of Payment (as % of service exports) in 2008 in Belize to that in Bolivia?
Give a very brief answer. 1.3. What is the ratio of the Balance of Payment (as % of service exports) of 2005 in Belize to that in Bosnia and Herzegovina?
Keep it short and to the point. 0.68. What is the ratio of the Balance of Payment (as % of service exports) in 2006 in Belize to that in Bosnia and Herzegovina?
Provide a succinct answer. 0.79. What is the ratio of the Balance of Payment (as % of service exports) in 2007 in Belize to that in Bosnia and Herzegovina?
Ensure brevity in your answer.  1.8. What is the ratio of the Balance of Payment (as % of service exports) in 2008 in Belize to that in Bosnia and Herzegovina?
Your response must be concise. 1.85. What is the ratio of the Balance of Payment (as % of service exports) in 2005 in Bolivia to that in Bosnia and Herzegovina?
Ensure brevity in your answer.  0.36. What is the ratio of the Balance of Payment (as % of service exports) in 2006 in Bolivia to that in Bosnia and Herzegovina?
Your response must be concise. 0.48. What is the ratio of the Balance of Payment (as % of service exports) of 2007 in Bolivia to that in Bosnia and Herzegovina?
Ensure brevity in your answer.  1.41. What is the ratio of the Balance of Payment (as % of service exports) of 2008 in Bolivia to that in Bosnia and Herzegovina?
Give a very brief answer. 1.43. What is the difference between the highest and the second highest Balance of Payment (as % of service exports) of 2005?
Keep it short and to the point. 15.9. What is the difference between the highest and the second highest Balance of Payment (as % of service exports) of 2006?
Your response must be concise. 8.22. What is the difference between the highest and the second highest Balance of Payment (as % of service exports) in 2007?
Provide a succinct answer. 4.25. What is the difference between the highest and the second highest Balance of Payment (as % of service exports) in 2008?
Ensure brevity in your answer.  1.01. What is the difference between the highest and the lowest Balance of Payment (as % of service exports) of 2005?
Keep it short and to the point. 27.88. What is the difference between the highest and the lowest Balance of Payment (as % of service exports) of 2006?
Your response must be concise. 25.24. What is the difference between the highest and the lowest Balance of Payment (as % of service exports) of 2007?
Give a very brief answer. 24.36. What is the difference between the highest and the lowest Balance of Payment (as % of service exports) in 2008?
Make the answer very short. 25.86. 